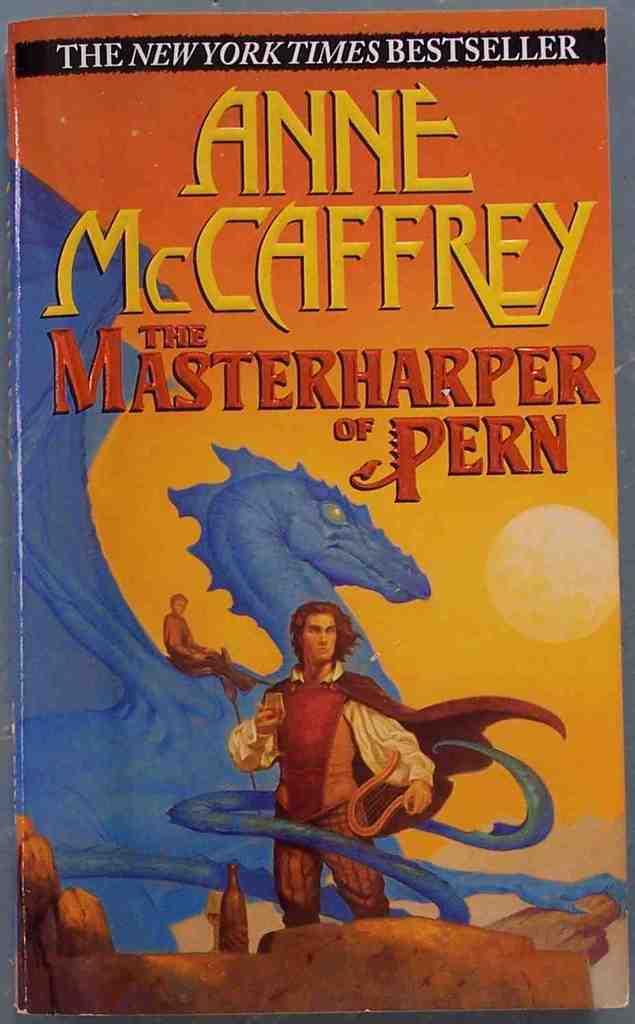Who is the author?
Your answer should be compact. Anne mccaffrey. 